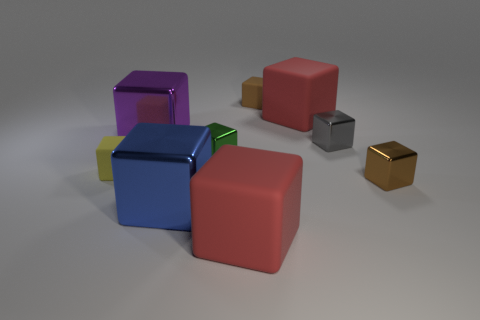What material is the big red object that is in front of the big metal thing to the left of the blue object made of?
Your response must be concise. Rubber. There is a shiny block that is on the right side of the small shiny block that is behind the tiny green metallic thing; what number of large matte cubes are right of it?
Offer a very short reply. 0. Is the material of the tiny brown thing that is on the left side of the gray shiny object the same as the tiny thing on the left side of the small green metallic object?
Give a very brief answer. Yes. How many big shiny things are the same shape as the tiny brown metallic thing?
Offer a terse response. 2. Are there more large things that are behind the small gray shiny thing than large green rubber blocks?
Give a very brief answer. Yes. The large rubber object that is behind the brown thing that is to the right of the small brown block behind the tiny brown metal cube is what shape?
Your answer should be compact. Cube. There is a red rubber thing that is on the left side of the small brown matte object; is its shape the same as the big matte object behind the big blue metal cube?
Your answer should be compact. Yes. Is there anything else that is the same size as the blue cube?
Your response must be concise. Yes. What number of spheres are either brown objects or purple things?
Make the answer very short. 0. Is the purple object made of the same material as the yellow block?
Offer a terse response. No. 